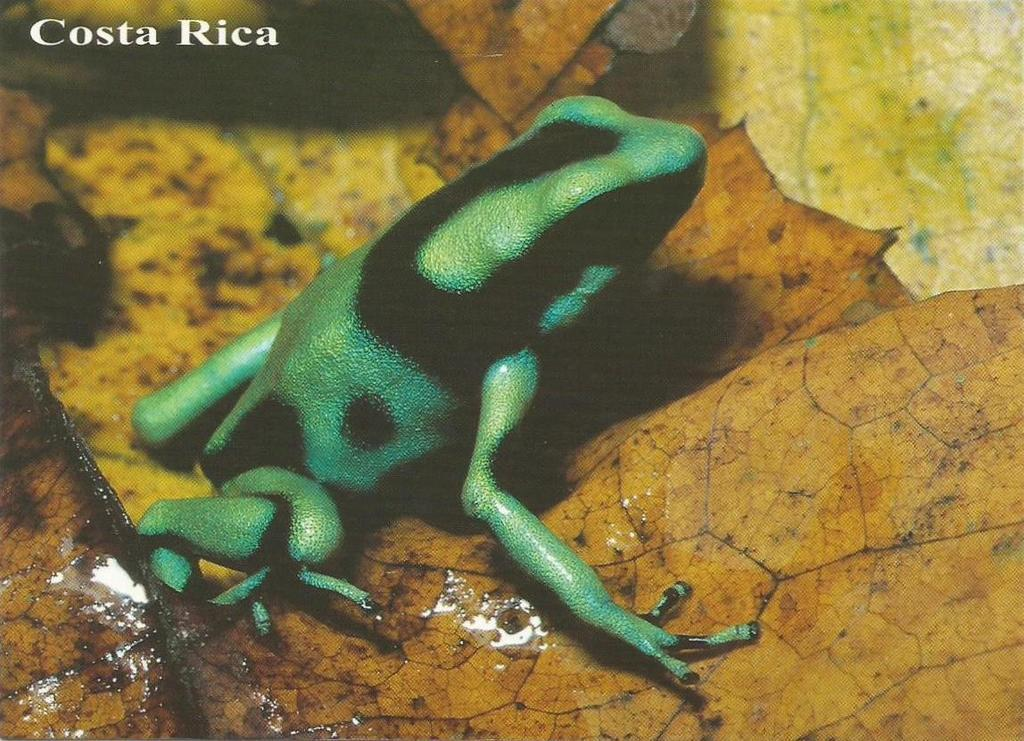What animal can be seen in the image? There is a frog in the image. What is the background of the image? The frog is on orange-yellow color leaves. Is there any text or marking in the image? Yes, a watermark is present in the top left corner of the image. What type of linen is the frog sitting on in the image? There is no linen present in the image; the frog is sitting on orange-yellow color leaves. 